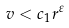Convert formula to latex. <formula><loc_0><loc_0><loc_500><loc_500>v < c _ { 1 } r ^ { \varepsilon }</formula> 